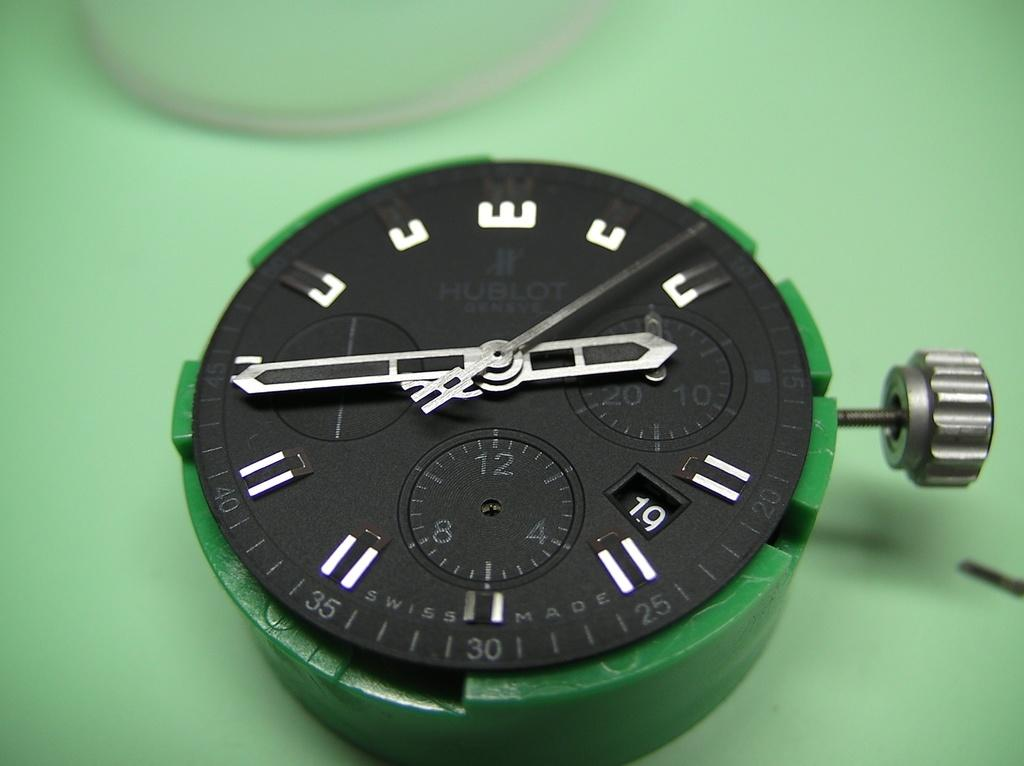Provide a one-sentence caption for the provided image. A watch face that has the minutes labeled along the edges, with 30 at the bottom. 